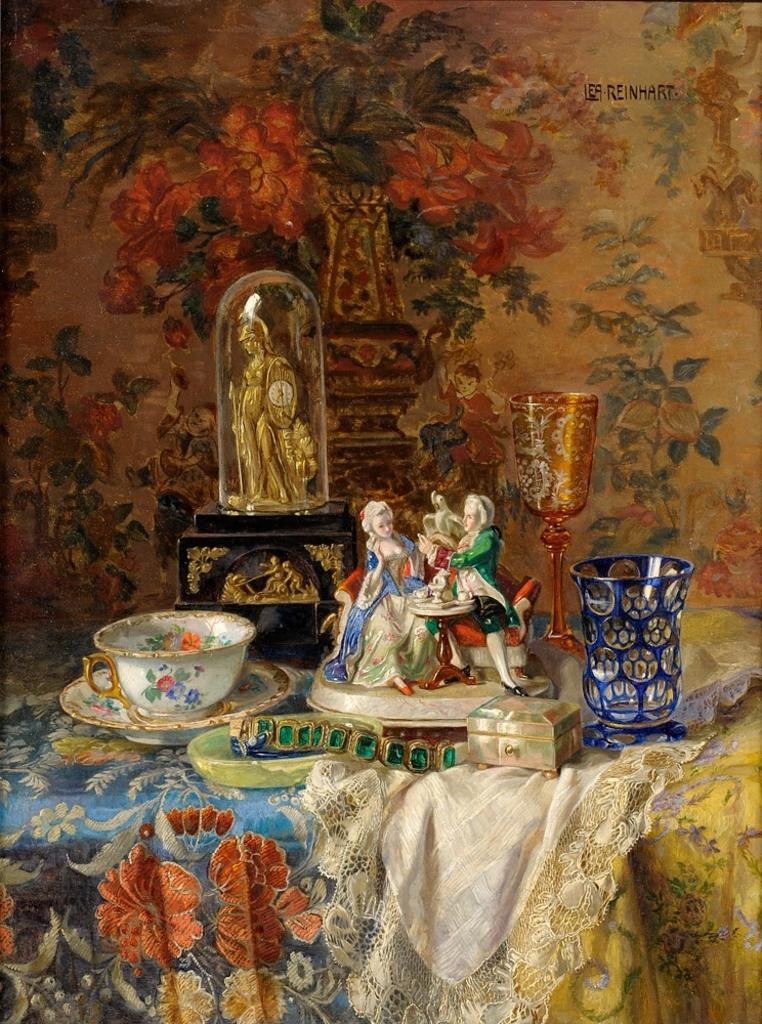What is the main subject of the image? There is a sculpture in the image. What else can be seen in the image besides the sculpture? There is a cup, a saucer, and glasses in the image. What type of pollution can be seen in the image? There is no pollution present in the image. What musical instrument is being played in the image? There is no musical instrument, such as a guitar, present in the image. 